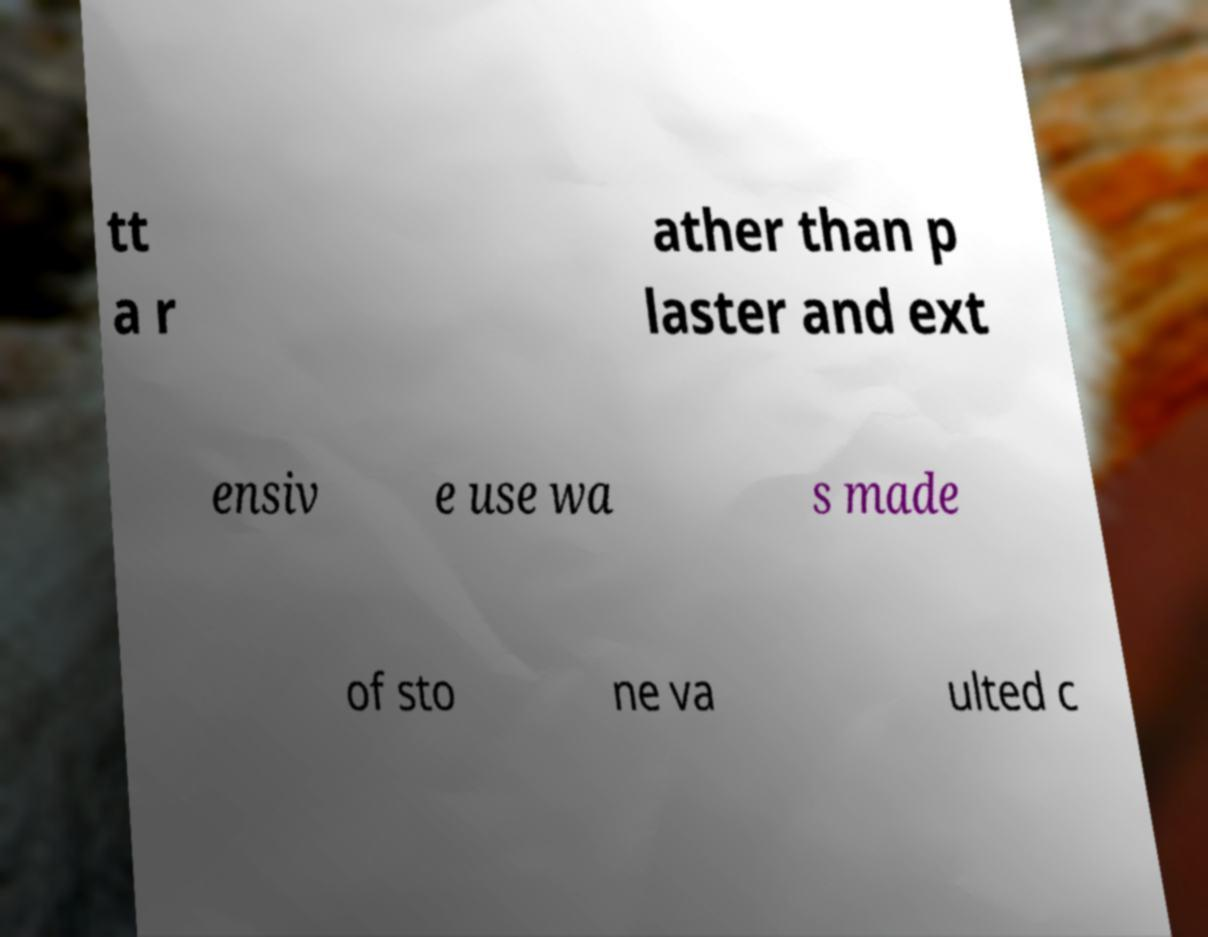Can you read and provide the text displayed in the image?This photo seems to have some interesting text. Can you extract and type it out for me? tt a r ather than p laster and ext ensiv e use wa s made of sto ne va ulted c 